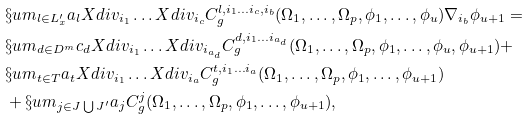<formula> <loc_0><loc_0><loc_500><loc_500>& \S u m _ { l \in L ^ { \prime } _ { x } } a _ { l } X d i v _ { i _ { 1 } } \dots X d i v _ { i _ { c } } C ^ { l , i _ { 1 } \dots i _ { c } , i _ { b } } _ { g } ( \Omega _ { 1 } , \dots , \Omega _ { p } , \phi _ { 1 } , \dots , \phi _ { u } ) \nabla _ { i _ { b } } \phi _ { u + 1 } = \\ & \S u m _ { d \in D ^ { m } } c _ { d } X d i v _ { i _ { 1 } } \dots X d i v _ { i _ { a _ { d } } } C ^ { d , i _ { 1 } \dots i _ { a _ { d } } } _ { g } ( \Omega _ { 1 } , \dots , \Omega _ { p } , \phi _ { 1 } , \dots , \phi _ { u } , \phi _ { u + 1 } ) + \\ & \S u m _ { t \in T } a _ { t } X d i v _ { i _ { 1 } } \dots X d i v _ { i _ { a } } C ^ { t , i _ { 1 } \dots i _ { a } } _ { g } ( \Omega _ { 1 } , \dots , \Omega _ { p } , \phi _ { 1 } , \dots , \phi _ { u + 1 } ) \\ & + \S u m _ { j \in J \bigcup J ^ { \prime } } a _ { j } C ^ { j } _ { g } ( \Omega _ { 1 } , \dots , \Omega _ { p } , \phi _ { 1 } , \dots , \phi _ { u + 1 } ) ,</formula> 